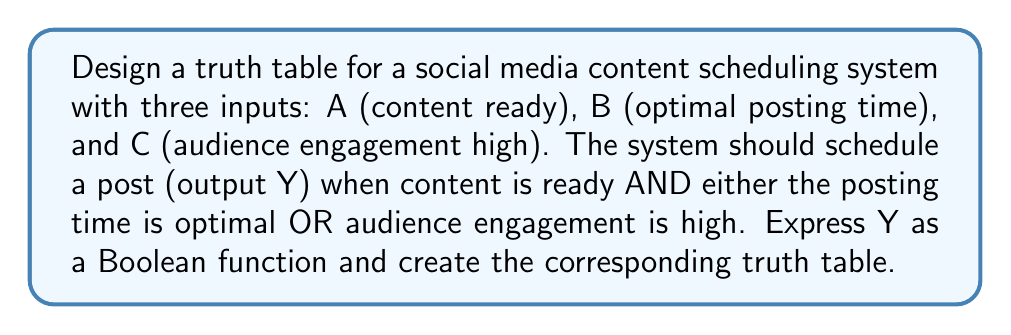Give your solution to this math problem. Step 1: Express the Boolean function
The given conditions can be translated into the following Boolean function:
$Y = A \cdot (B + C)$

Step 2: Identify input combinations
We have 3 inputs (A, B, C), so there are $2^3 = 8$ possible input combinations.

Step 3: Evaluate the function for each input combination
Let's evaluate Y for each combination:

1. A = 0, B = 0, C = 0: $Y = 0 \cdot (0 + 0) = 0 \cdot 0 = 0$
2. A = 0, B = 0, C = 1: $Y = 0 \cdot (0 + 1) = 0 \cdot 1 = 0$
3. A = 0, B = 1, C = 0: $Y = 0 \cdot (1 + 0) = 0 \cdot 1 = 0$
4. A = 0, B = 1, C = 1: $Y = 0 \cdot (1 + 1) = 0 \cdot 1 = 0$
5. A = 1, B = 0, C = 0: $Y = 1 \cdot (0 + 0) = 1 \cdot 0 = 0$
6. A = 1, B = 0, C = 1: $Y = 1 \cdot (0 + 1) = 1 \cdot 1 = 1$
7. A = 1, B = 1, C = 0: $Y = 1 \cdot (1 + 0) = 1 \cdot 1 = 1$
8. A = 1, B = 1, C = 1: $Y = 1 \cdot (1 + 1) = 1 \cdot 1 = 1$

Step 4: Construct the truth table
Based on the evaluations, we can construct the following truth table:

$$
\begin{array}{|c|c|c|c|}
\hline
A & B & C & Y \\
\hline
0 & 0 & 0 & 0 \\
0 & 0 & 1 & 0 \\
0 & 1 & 0 & 0 \\
0 & 1 & 1 & 0 \\
1 & 0 & 0 & 0 \\
1 & 0 & 1 & 1 \\
1 & 1 & 0 & 1 \\
1 & 1 & 1 & 1 \\
\hline
\end{array}
$$

This truth table represents the behavior of the social media content scheduling system based on the given conditions.
Answer: $Y = A \cdot (B + C)$, with truth table:
$$
\begin{array}{|c|c|c|c|}
\hline
A & B & C & Y \\
\hline
0 & 0 & 0 & 0 \\
0 & 0 & 1 & 0 \\
0 & 1 & 0 & 0 \\
0 & 1 & 1 & 0 \\
1 & 0 & 0 & 0 \\
1 & 0 & 1 & 1 \\
1 & 1 & 0 & 1 \\
1 & 1 & 1 & 1 \\
\hline
\end{array}
$$ 